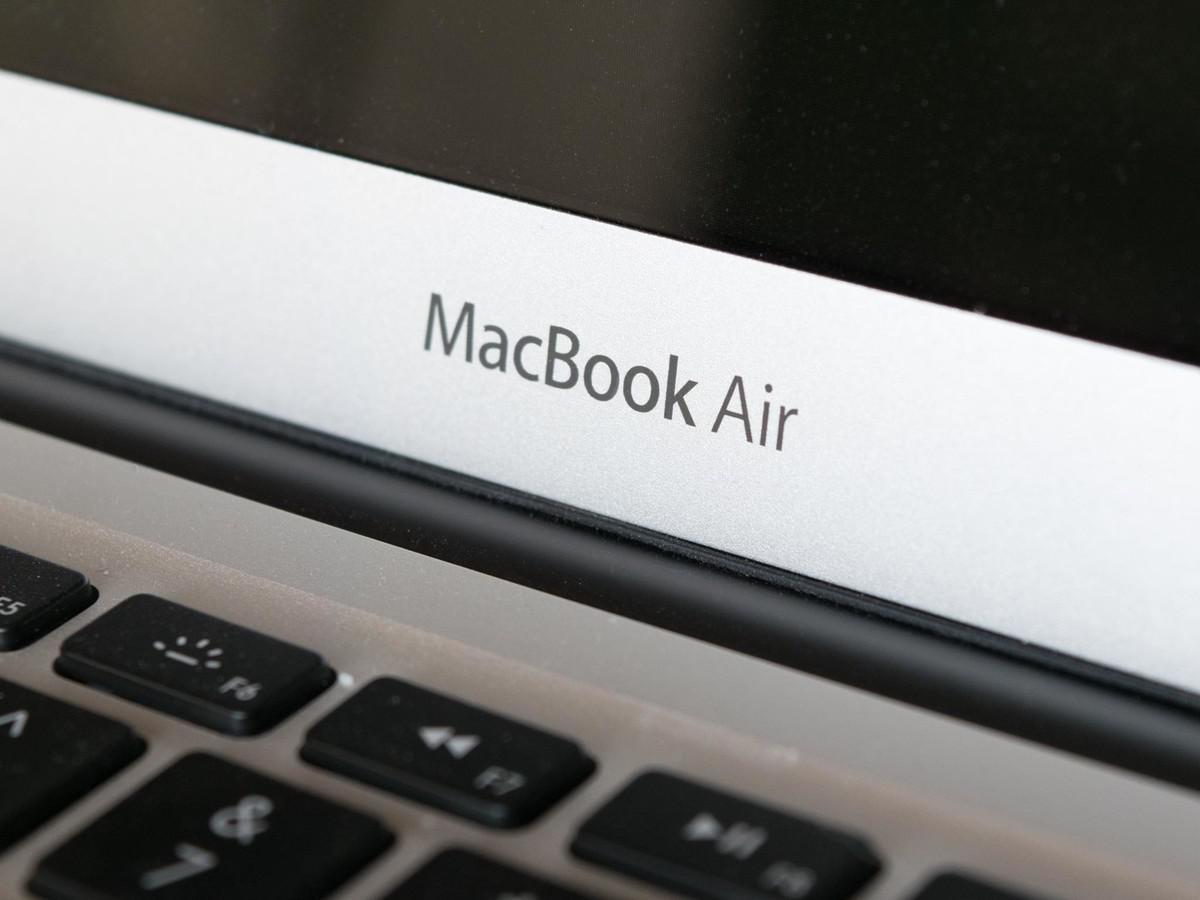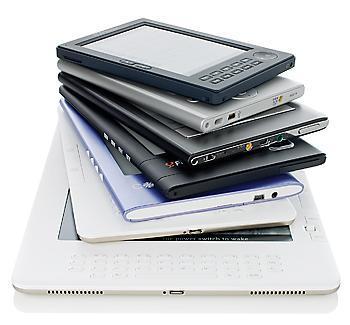The first image is the image on the left, the second image is the image on the right. Examine the images to the left and right. Is the description "The left image shows a neat stack of at least three white laptop-type devices." accurate? Answer yes or no. No. The first image is the image on the left, the second image is the image on the right. For the images displayed, is the sentence "In the image to the right, several electronic objects are stacked on top of each other." factually correct? Answer yes or no. Yes. 